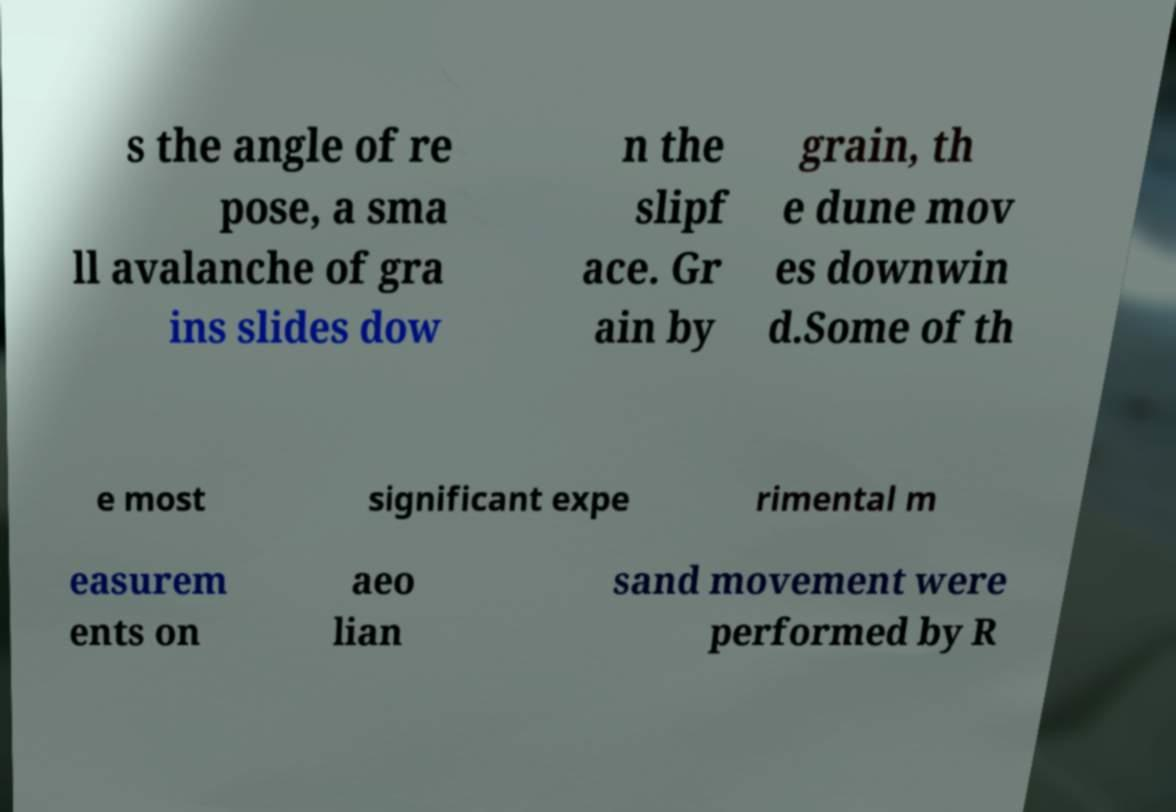There's text embedded in this image that I need extracted. Can you transcribe it verbatim? s the angle of re pose, a sma ll avalanche of gra ins slides dow n the slipf ace. Gr ain by grain, th e dune mov es downwin d.Some of th e most significant expe rimental m easurem ents on aeo lian sand movement were performed by R 